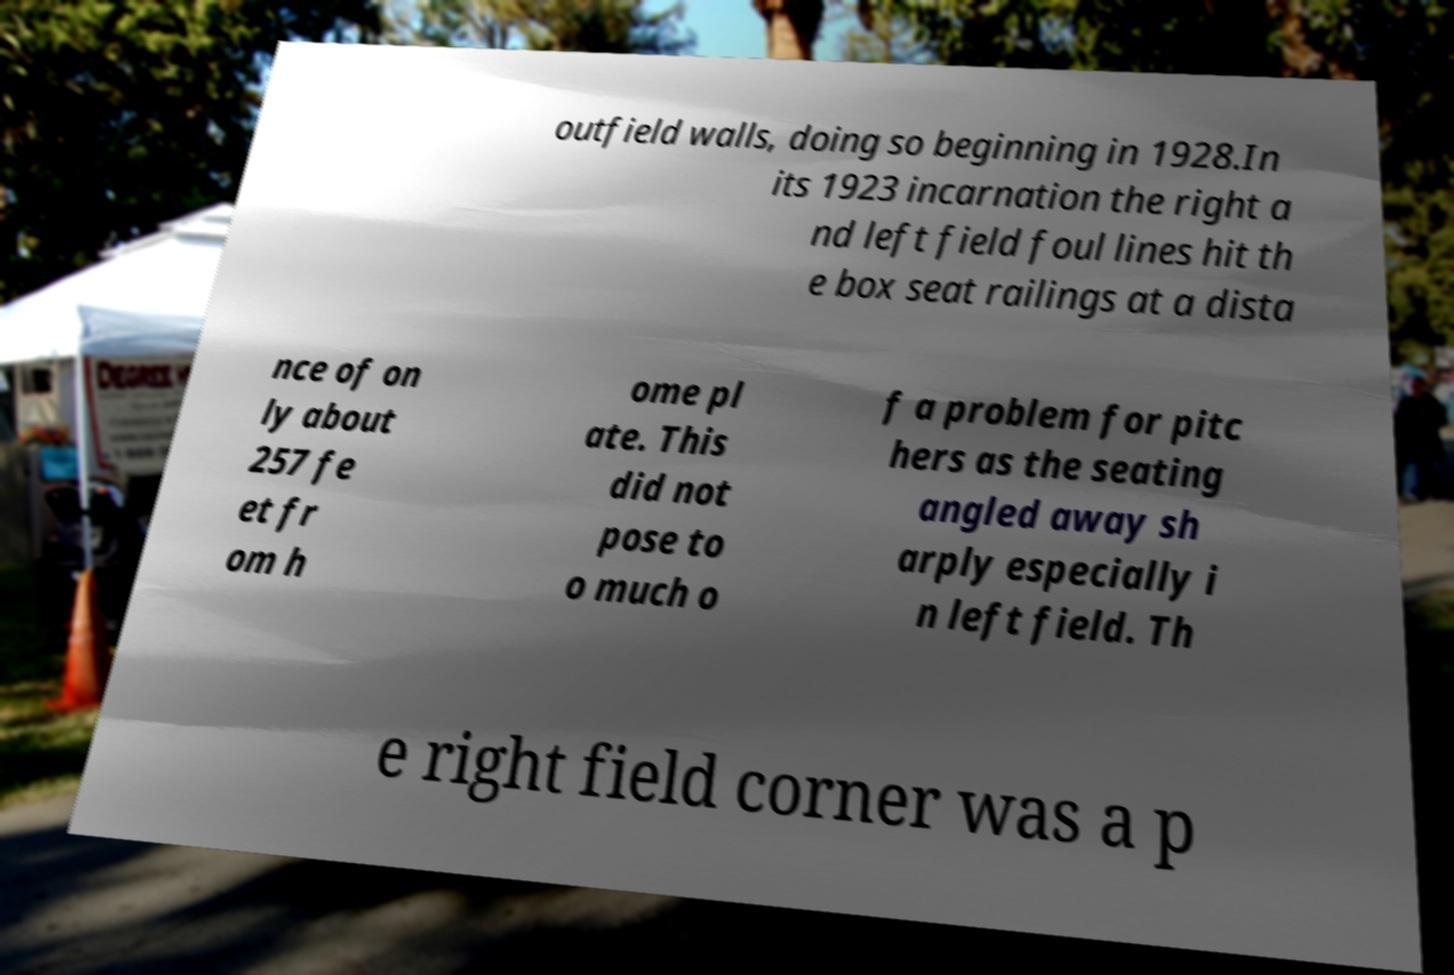Could you extract and type out the text from this image? outfield walls, doing so beginning in 1928.In its 1923 incarnation the right a nd left field foul lines hit th e box seat railings at a dista nce of on ly about 257 fe et fr om h ome pl ate. This did not pose to o much o f a problem for pitc hers as the seating angled away sh arply especially i n left field. Th e right field corner was a p 